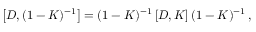Convert formula to latex. <formula><loc_0><loc_0><loc_500><loc_500>\left [ D , ( 1 - K ) ^ { - 1 } \right ] = ( 1 - K ) ^ { - 1 } \left [ D , K \right ] ( 1 - K ) ^ { - 1 } \, ,</formula> 